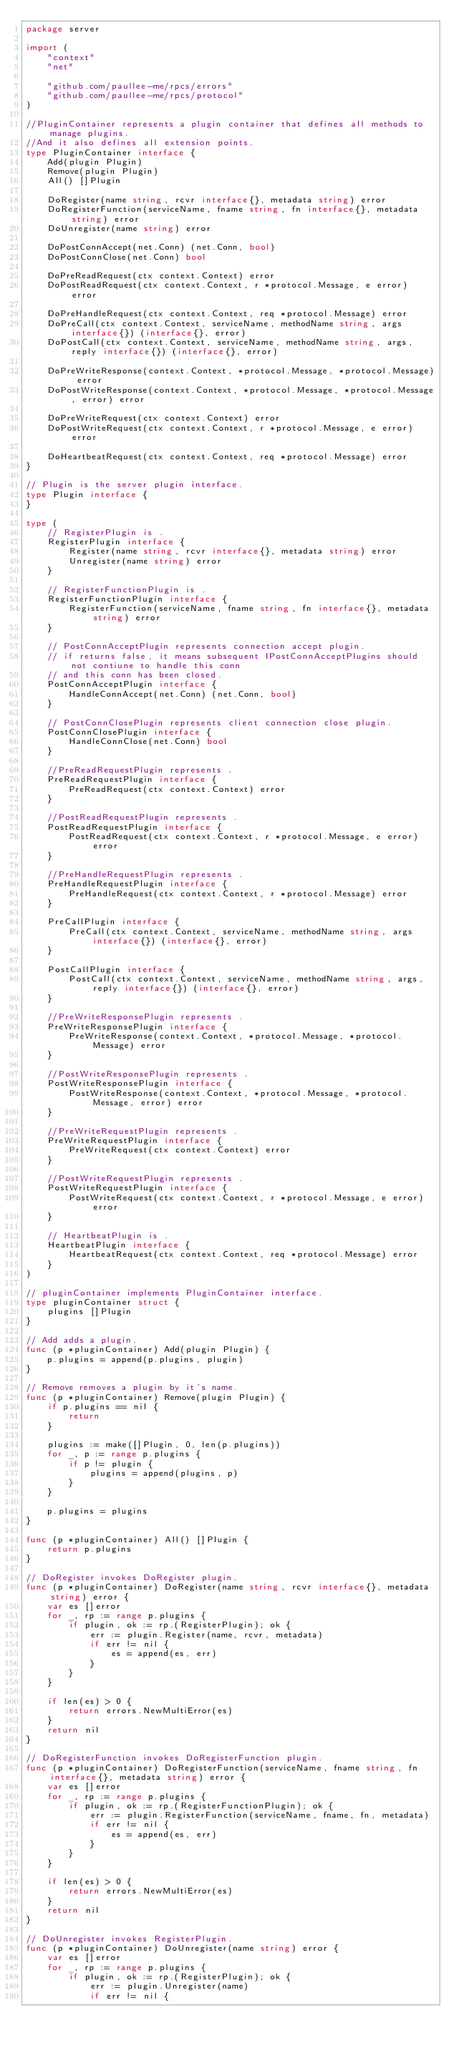<code> <loc_0><loc_0><loc_500><loc_500><_Go_>package server

import (
	"context"
	"net"

	"github.com/paullee-me/rpcs/errors"
	"github.com/paullee-me/rpcs/protocol"
)

//PluginContainer represents a plugin container that defines all methods to manage plugins.
//And it also defines all extension points.
type PluginContainer interface {
	Add(plugin Plugin)
	Remove(plugin Plugin)
	All() []Plugin

	DoRegister(name string, rcvr interface{}, metadata string) error
	DoRegisterFunction(serviceName, fname string, fn interface{}, metadata string) error
	DoUnregister(name string) error

	DoPostConnAccept(net.Conn) (net.Conn, bool)
	DoPostConnClose(net.Conn) bool

	DoPreReadRequest(ctx context.Context) error
	DoPostReadRequest(ctx context.Context, r *protocol.Message, e error) error

	DoPreHandleRequest(ctx context.Context, req *protocol.Message) error
	DoPreCall(ctx context.Context, serviceName, methodName string, args interface{}) (interface{}, error)
	DoPostCall(ctx context.Context, serviceName, methodName string, args, reply interface{}) (interface{}, error)

	DoPreWriteResponse(context.Context, *protocol.Message, *protocol.Message) error
	DoPostWriteResponse(context.Context, *protocol.Message, *protocol.Message, error) error

	DoPreWriteRequest(ctx context.Context) error
	DoPostWriteRequest(ctx context.Context, r *protocol.Message, e error) error

	DoHeartbeatRequest(ctx context.Context, req *protocol.Message) error
}

// Plugin is the server plugin interface.
type Plugin interface {
}

type (
	// RegisterPlugin is .
	RegisterPlugin interface {
		Register(name string, rcvr interface{}, metadata string) error
		Unregister(name string) error
	}

	// RegisterFunctionPlugin is .
	RegisterFunctionPlugin interface {
		RegisterFunction(serviceName, fname string, fn interface{}, metadata string) error
	}

	// PostConnAcceptPlugin represents connection accept plugin.
	// if returns false, it means subsequent IPostConnAcceptPlugins should not contiune to handle this conn
	// and this conn has been closed.
	PostConnAcceptPlugin interface {
		HandleConnAccept(net.Conn) (net.Conn, bool)
	}

	// PostConnClosePlugin represents client connection close plugin.
	PostConnClosePlugin interface {
		HandleConnClose(net.Conn) bool
	}

	//PreReadRequestPlugin represents .
	PreReadRequestPlugin interface {
		PreReadRequest(ctx context.Context) error
	}

	//PostReadRequestPlugin represents .
	PostReadRequestPlugin interface {
		PostReadRequest(ctx context.Context, r *protocol.Message, e error) error
	}

	//PreHandleRequestPlugin represents .
	PreHandleRequestPlugin interface {
		PreHandleRequest(ctx context.Context, r *protocol.Message) error
	}

	PreCallPlugin interface {
		PreCall(ctx context.Context, serviceName, methodName string, args interface{}) (interface{}, error)
	}

	PostCallPlugin interface {
		PostCall(ctx context.Context, serviceName, methodName string, args, reply interface{}) (interface{}, error)
	}

	//PreWriteResponsePlugin represents .
	PreWriteResponsePlugin interface {
		PreWriteResponse(context.Context, *protocol.Message, *protocol.Message) error
	}

	//PostWriteResponsePlugin represents .
	PostWriteResponsePlugin interface {
		PostWriteResponse(context.Context, *protocol.Message, *protocol.Message, error) error
	}

	//PreWriteRequestPlugin represents .
	PreWriteRequestPlugin interface {
		PreWriteRequest(ctx context.Context) error
	}

	//PostWriteRequestPlugin represents .
	PostWriteRequestPlugin interface {
		PostWriteRequest(ctx context.Context, r *protocol.Message, e error) error
	}

	// HeartbeatPlugin is .
	HeartbeatPlugin interface {
		HeartbeatRequest(ctx context.Context, req *protocol.Message) error
	}
)

// pluginContainer implements PluginContainer interface.
type pluginContainer struct {
	plugins []Plugin
}

// Add adds a plugin.
func (p *pluginContainer) Add(plugin Plugin) {
	p.plugins = append(p.plugins, plugin)
}

// Remove removes a plugin by it's name.
func (p *pluginContainer) Remove(plugin Plugin) {
	if p.plugins == nil {
		return
	}

	plugins := make([]Plugin, 0, len(p.plugins))
	for _, p := range p.plugins {
		if p != plugin {
			plugins = append(plugins, p)
		}
	}

	p.plugins = plugins
}

func (p *pluginContainer) All() []Plugin {
	return p.plugins
}

// DoRegister invokes DoRegister plugin.
func (p *pluginContainer) DoRegister(name string, rcvr interface{}, metadata string) error {
	var es []error
	for _, rp := range p.plugins {
		if plugin, ok := rp.(RegisterPlugin); ok {
			err := plugin.Register(name, rcvr, metadata)
			if err != nil {
				es = append(es, err)
			}
		}
	}

	if len(es) > 0 {
		return errors.NewMultiError(es)
	}
	return nil
}

// DoRegisterFunction invokes DoRegisterFunction plugin.
func (p *pluginContainer) DoRegisterFunction(serviceName, fname string, fn interface{}, metadata string) error {
	var es []error
	for _, rp := range p.plugins {
		if plugin, ok := rp.(RegisterFunctionPlugin); ok {
			err := plugin.RegisterFunction(serviceName, fname, fn, metadata)
			if err != nil {
				es = append(es, err)
			}
		}
	}

	if len(es) > 0 {
		return errors.NewMultiError(es)
	}
	return nil
}

// DoUnregister invokes RegisterPlugin.
func (p *pluginContainer) DoUnregister(name string) error {
	var es []error
	for _, rp := range p.plugins {
		if plugin, ok := rp.(RegisterPlugin); ok {
			err := plugin.Unregister(name)
			if err != nil {</code> 